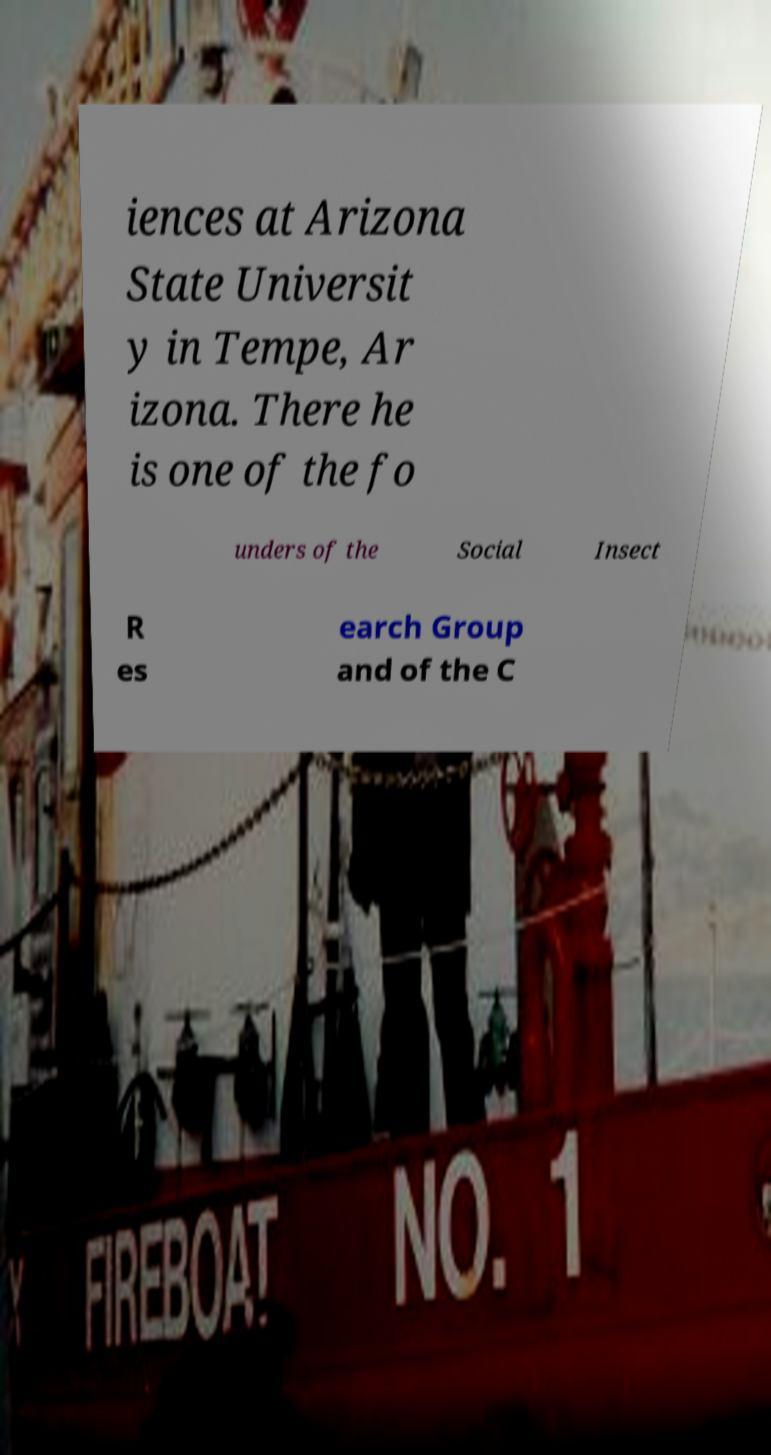Could you assist in decoding the text presented in this image and type it out clearly? iences at Arizona State Universit y in Tempe, Ar izona. There he is one of the fo unders of the Social Insect R es earch Group and of the C 